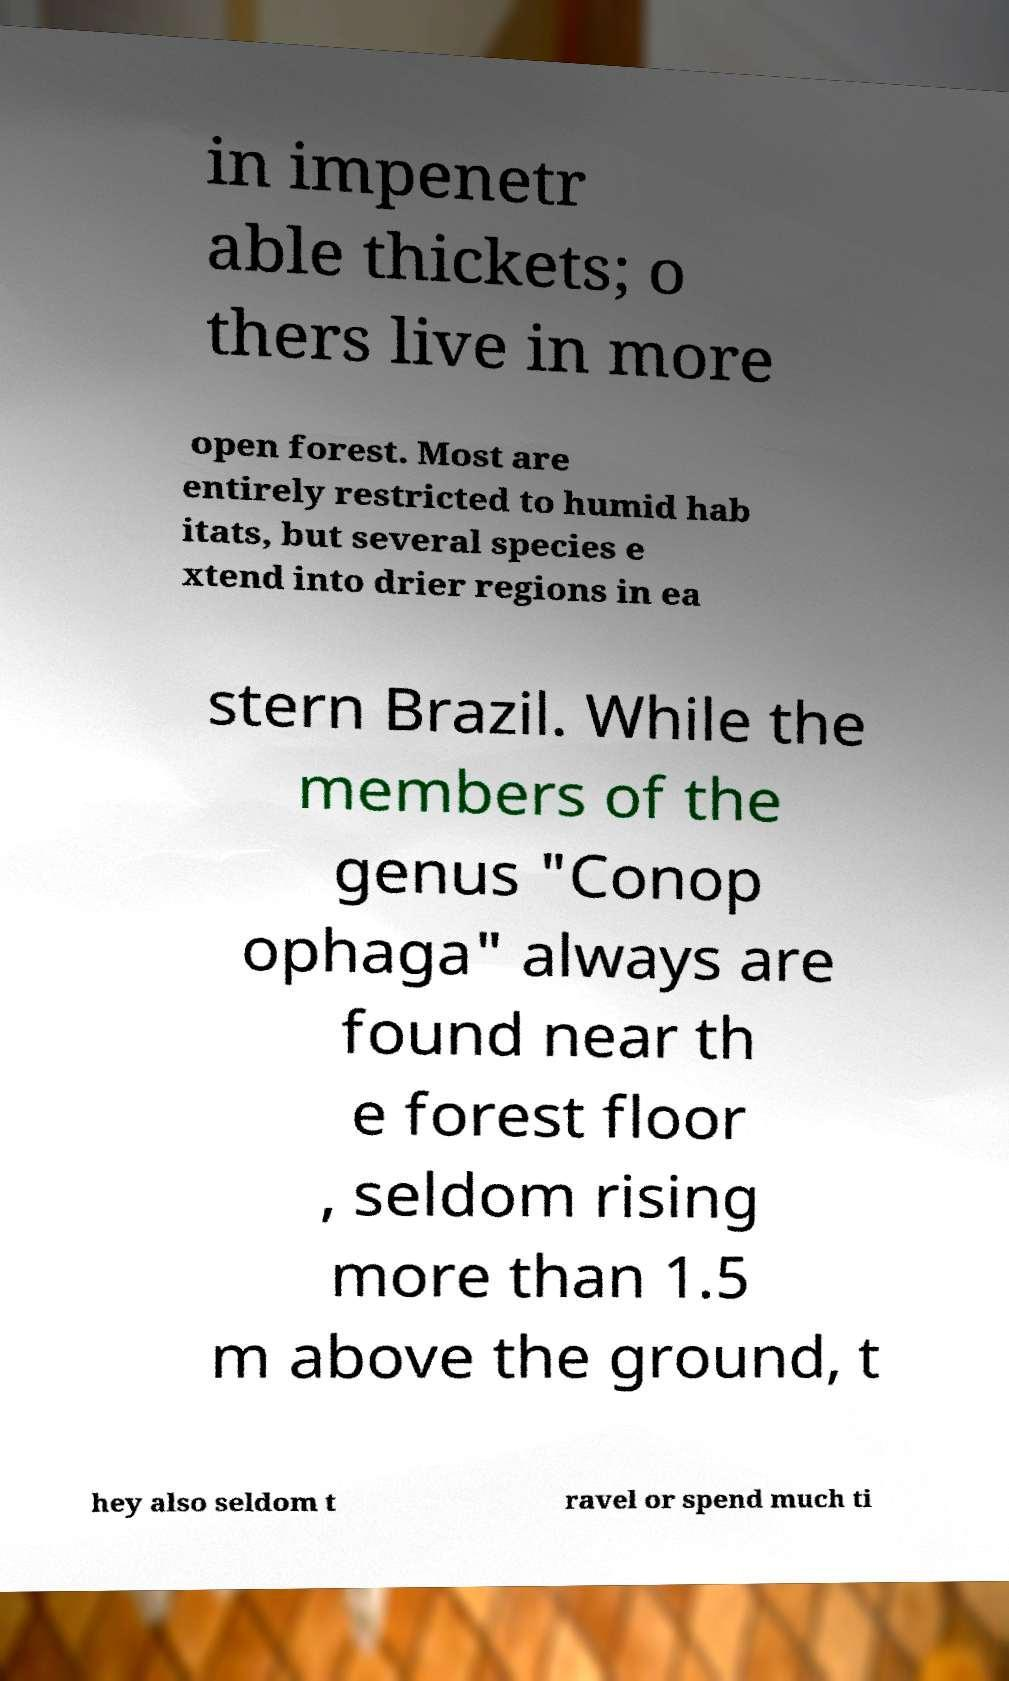Please read and relay the text visible in this image. What does it say? in impenetr able thickets; o thers live in more open forest. Most are entirely restricted to humid hab itats, but several species e xtend into drier regions in ea stern Brazil. While the members of the genus "Conop ophaga" always are found near th e forest floor , seldom rising more than 1.5 m above the ground, t hey also seldom t ravel or spend much ti 